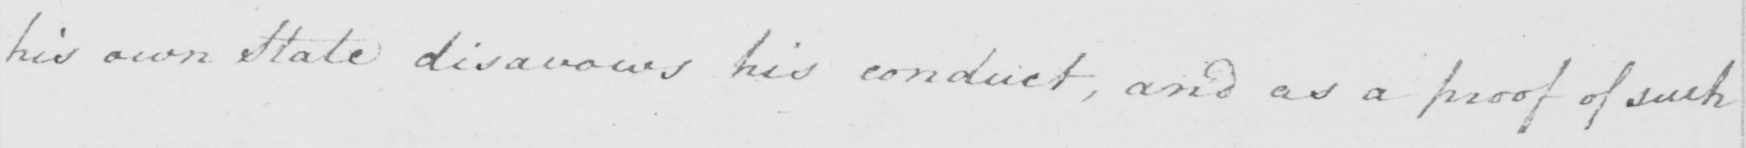What text is written in this handwritten line? his own State disavows his conduct , and as a proof of such 